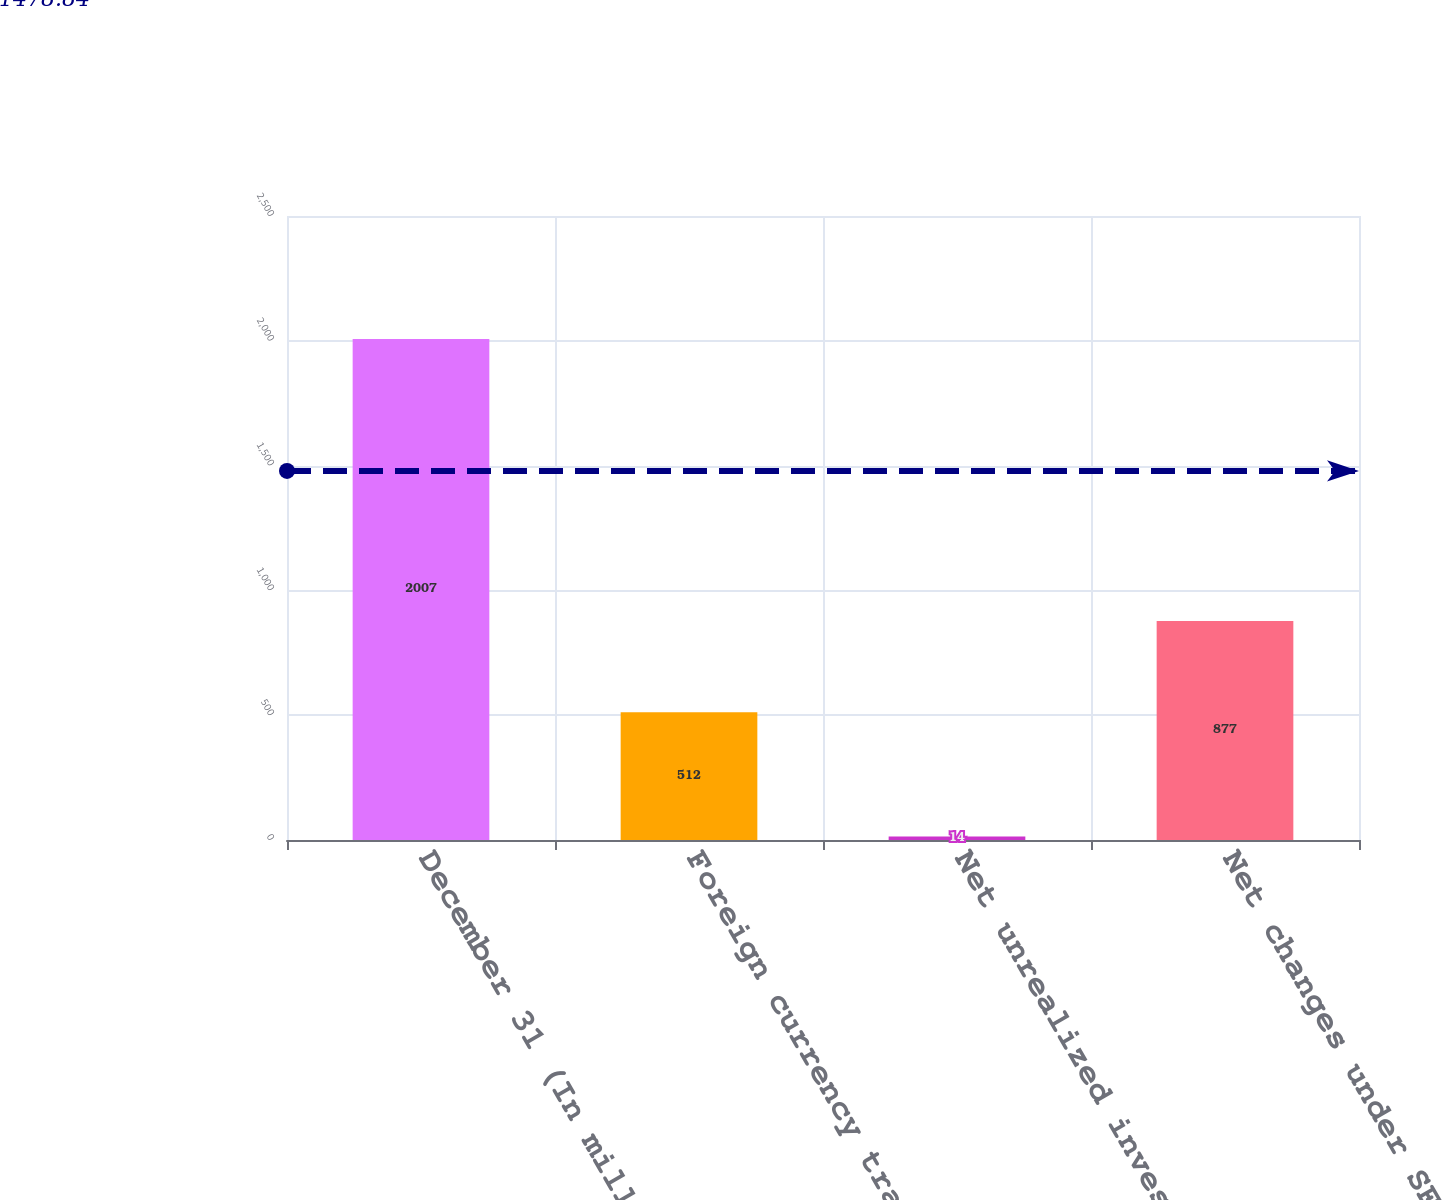Convert chart. <chart><loc_0><loc_0><loc_500><loc_500><bar_chart><fcel>December 31 (In millions of<fcel>Foreign currency translation<fcel>Net unrealized investment<fcel>Net changes under SFAS 158<nl><fcel>2007<fcel>512<fcel>14<fcel>877<nl></chart> 